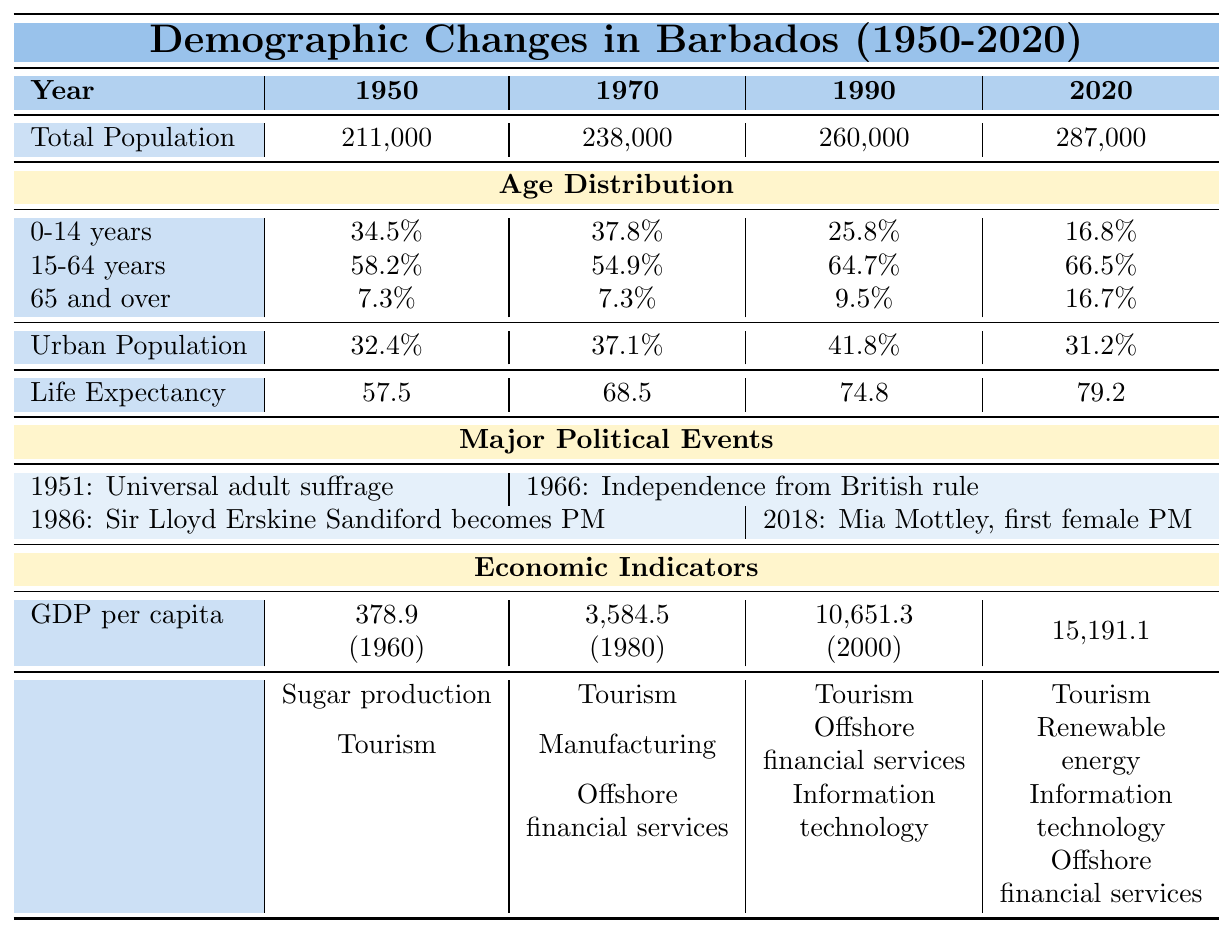What was the total population of Barbados in 1990? The table shows the total population of Barbados in 1990 as 260,000.
Answer: 260,000 Which age group saw the largest percentage decrease from 1950 to 2020? In 1950, the 0-14 years age group was 34.5%, and by 2020 it decreased to 16.8%. This is a decrease of 17.7 percentage points. The 15-64 years group increased from 58.2% to 66.5%, and the 65 and over group increased from 7.3% to 16.7%. Thus, the 0-14 years group had the largest decrease.
Answer: 0-14 years What is the life expectancy in Barbados in 2000? The life expectancy in Barbados in 2000 is given as 74.8 years.
Answer: 74.8 Was the urban population higher in 1990 or 2020? The urban population in 1990 was 41.8%, while in 2020 it decreased to 31.2%. Therefore, it was higher in 1990.
Answer: 1990 What was the change in life expectancy from 1950 to 2020? Life expectancy in 1950 was 57.5 years, and in 2020 it increased to 79.2 years. The change is 79.2 - 57.5 = 21.7 years.
Answer: 21.7 years In which year did Barbados gain independence from British rule? According to the major political events, Barbados gained independence from British rule in 1966.
Answer: 1966 What is the GDP per capita in 1980? The GDP per capita in 1980 is provided as 3,584.5 current US dollars.
Answer: 3,584.5 Which two years had the same percentage of people aged 65 and over? Both 1950 and 1970 had the same percentage of people aged 65 and over at 7.3%.
Answer: 1950 and 1970 What was the main industry in Barbados in 1960? The main industry in Barbados in 1960 was sugar production, as stated in the economic indicators.
Answer: Sugar production Did the total population of Barbados increase or decrease from 1990 to 2020? The total population increased from 260,000 in 1990 to 287,000 in 2020, indicating growth.
Answer: Increased What percentage of the population was aged 15-64 in 1970? The percentage of the population aged 15-64 years in 1970 is 54.9%, as shown in the age distribution.
Answer: 54.9% If you average the GDP per capita for the years provided (1960, 1980, 2000, 2020), what would it be? The GDP per capita values are 378.9, 3,584.5, 10,651.3, and 15,191.1. The total is 378.9 + 3,584.5 + 10,651.3 + 15,191.1 = 29,805.8. Dividing by 4 gives an average of 7,451.45.
Answer: 7,451.45 Which decade saw the largest increase in life expectancy? Life expectancy increased from 57.5 in 1950 to 68.5 in 1970 (11 years), and from 68.5 in 1970 to 74.8 in 1990 (6.3 years), and then to 79.2 in 2020 (4.4 years). The largest increase was from 1950 to 1970 with 11 years.
Answer: 1950 to 1970 What proportion of the population aged 0-14 years in 2020 compared to that in 1970? The percentage of the population aged 0-14 years in 2020 is 16.8% and in 1970 it was 37.8%. The proportion is 16.8 / 37.8 = 0.444, or approximately 44.4%.
Answer: 44.4% 